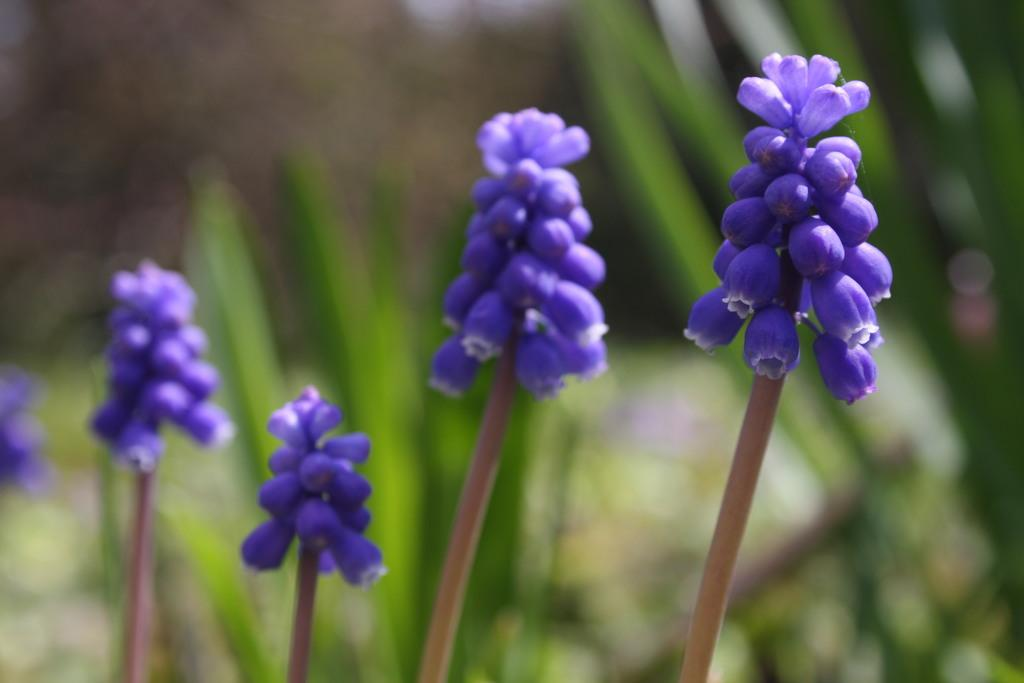What type of flowers are in the image? There are grape hyacinths in the image. What color are the grape hyacinths? The grape hyacinths are violet in color. Can you describe the background of the image? The background of the image is blurry. What book is the zebra reading in the image? There is no book or zebra present in the image; it features grape hyacinths with a blurry background. 